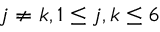Convert formula to latex. <formula><loc_0><loc_0><loc_500><loc_500>j \neq k , 1 \leq j , k \leq 6</formula> 